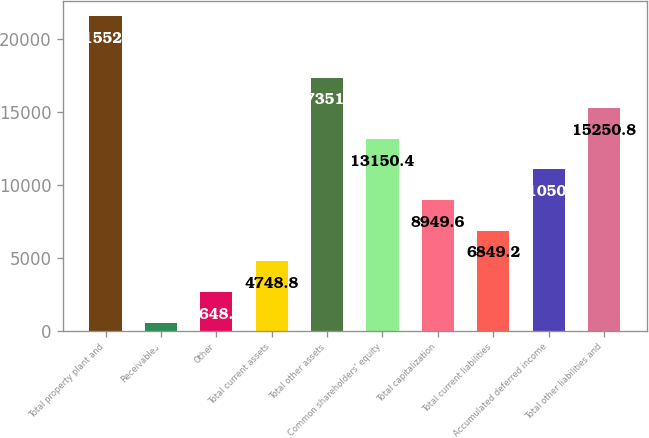Convert chart. <chart><loc_0><loc_0><loc_500><loc_500><bar_chart><fcel>Total property plant and<fcel>Receivables<fcel>Other<fcel>Total current assets<fcel>Total other assets<fcel>Common shareholders' equity<fcel>Total capitalization<fcel>Total current liabilities<fcel>Accumulated deferred income<fcel>Total other liabilities and<nl><fcel>21552<fcel>548<fcel>2648.4<fcel>4748.8<fcel>17351.2<fcel>13150.4<fcel>8949.6<fcel>6849.2<fcel>11050<fcel>15250.8<nl></chart> 